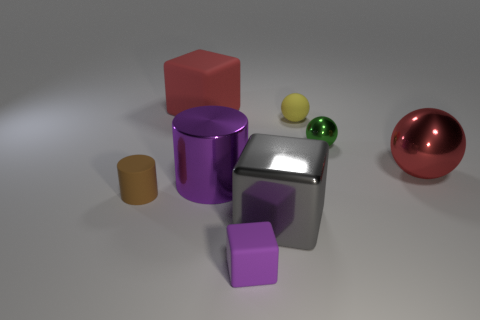Add 2 big gray metal objects. How many objects exist? 10 Subtract all spheres. How many objects are left? 5 Subtract all metallic cylinders. Subtract all tiny yellow balls. How many objects are left? 6 Add 1 purple rubber things. How many purple rubber things are left? 2 Add 2 big brown shiny cylinders. How many big brown shiny cylinders exist? 2 Subtract 0 green cylinders. How many objects are left? 8 